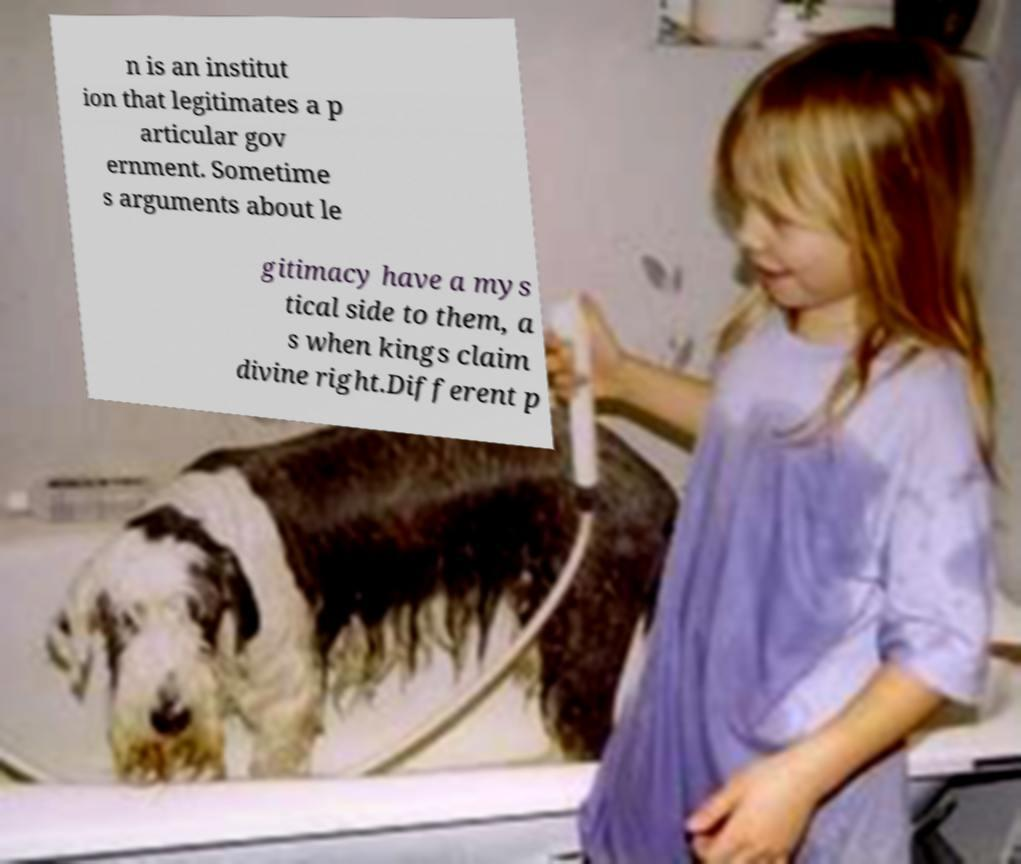Could you assist in decoding the text presented in this image and type it out clearly? n is an institut ion that legitimates a p articular gov ernment. Sometime s arguments about le gitimacy have a mys tical side to them, a s when kings claim divine right.Different p 